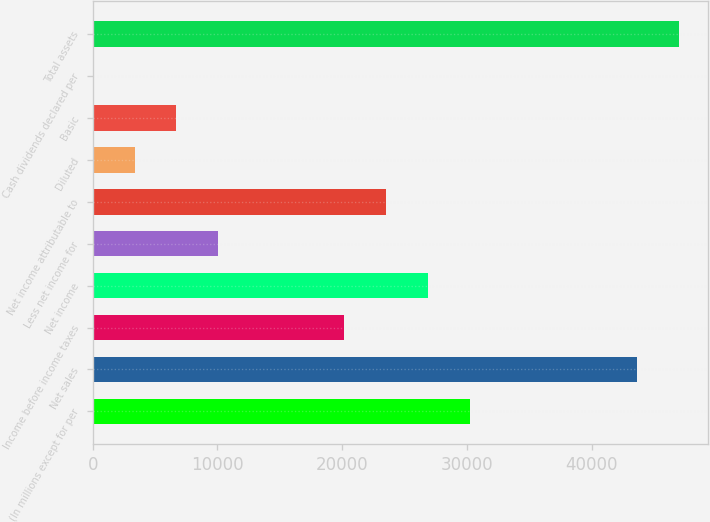Convert chart. <chart><loc_0><loc_0><loc_500><loc_500><bar_chart><fcel>(In millions except for per<fcel>Net sales<fcel>Income before income taxes<fcel>Net income<fcel>Less net income for<fcel>Net income attributable to<fcel>Diluted<fcel>Basic<fcel>Cash dividends declared per<fcel>Total assets<nl><fcel>30201.5<fcel>43623.5<fcel>20135<fcel>26846<fcel>10068.5<fcel>23490.5<fcel>3357.46<fcel>6712.96<fcel>1.96<fcel>46979<nl></chart> 